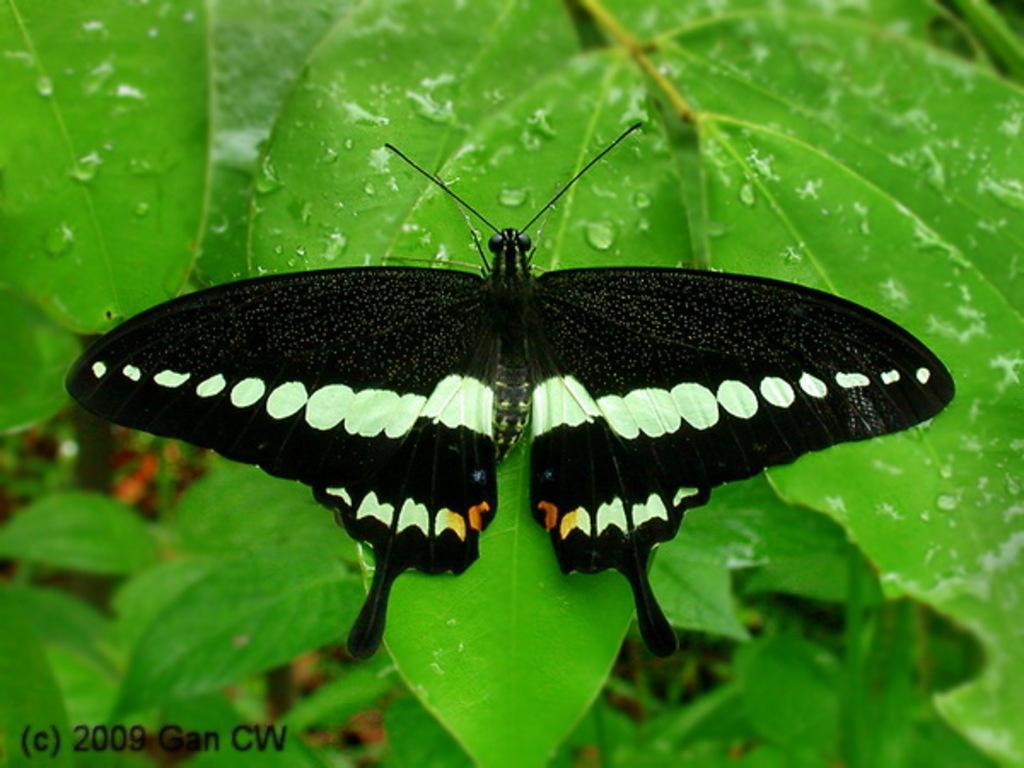In one or two sentences, can you explain what this image depicts? In the center of the image we can see a few leaves with water drops on it. And we can see one butterfly on one of the leaves. At the bottom left side of the image, we can see some text. In the background, we can see it is blurred. 